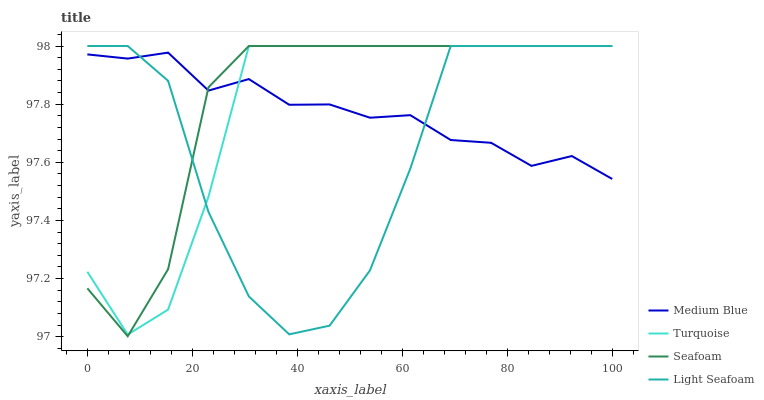Does Light Seafoam have the minimum area under the curve?
Answer yes or no. Yes. Does Seafoam have the maximum area under the curve?
Answer yes or no. Yes. Does Medium Blue have the minimum area under the curve?
Answer yes or no. No. Does Medium Blue have the maximum area under the curve?
Answer yes or no. No. Is Medium Blue the smoothest?
Answer yes or no. Yes. Is Light Seafoam the roughest?
Answer yes or no. Yes. Is Light Seafoam the smoothest?
Answer yes or no. No. Is Medium Blue the roughest?
Answer yes or no. No. Does Seafoam have the lowest value?
Answer yes or no. Yes. Does Light Seafoam have the lowest value?
Answer yes or no. No. Does Seafoam have the highest value?
Answer yes or no. Yes. Does Medium Blue have the highest value?
Answer yes or no. No. Does Light Seafoam intersect Seafoam?
Answer yes or no. Yes. Is Light Seafoam less than Seafoam?
Answer yes or no. No. Is Light Seafoam greater than Seafoam?
Answer yes or no. No. 